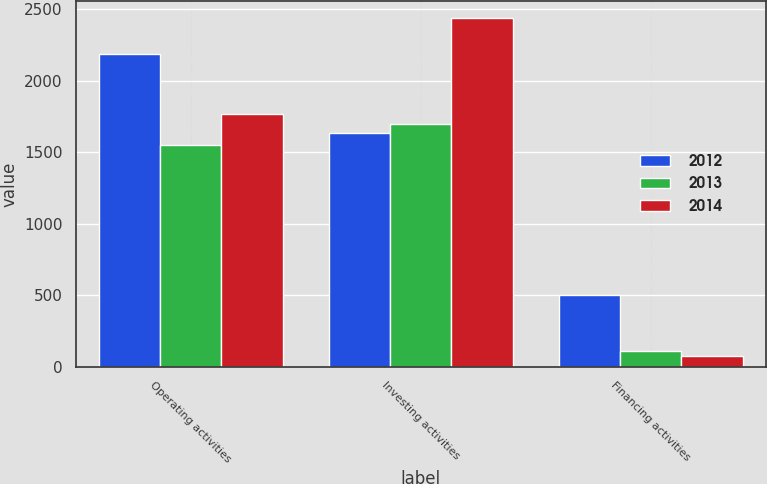Convert chart. <chart><loc_0><loc_0><loc_500><loc_500><stacked_bar_chart><ecel><fcel>Operating activities<fcel>Investing activities<fcel>Financing activities<nl><fcel>2012<fcel>2186.4<fcel>1638<fcel>504.3<nl><fcel>2013<fcel>1553.1<fcel>1697<fcel>115.4<nl><fcel>2014<fcel>1765.1<fcel>2435.2<fcel>78.4<nl></chart> 